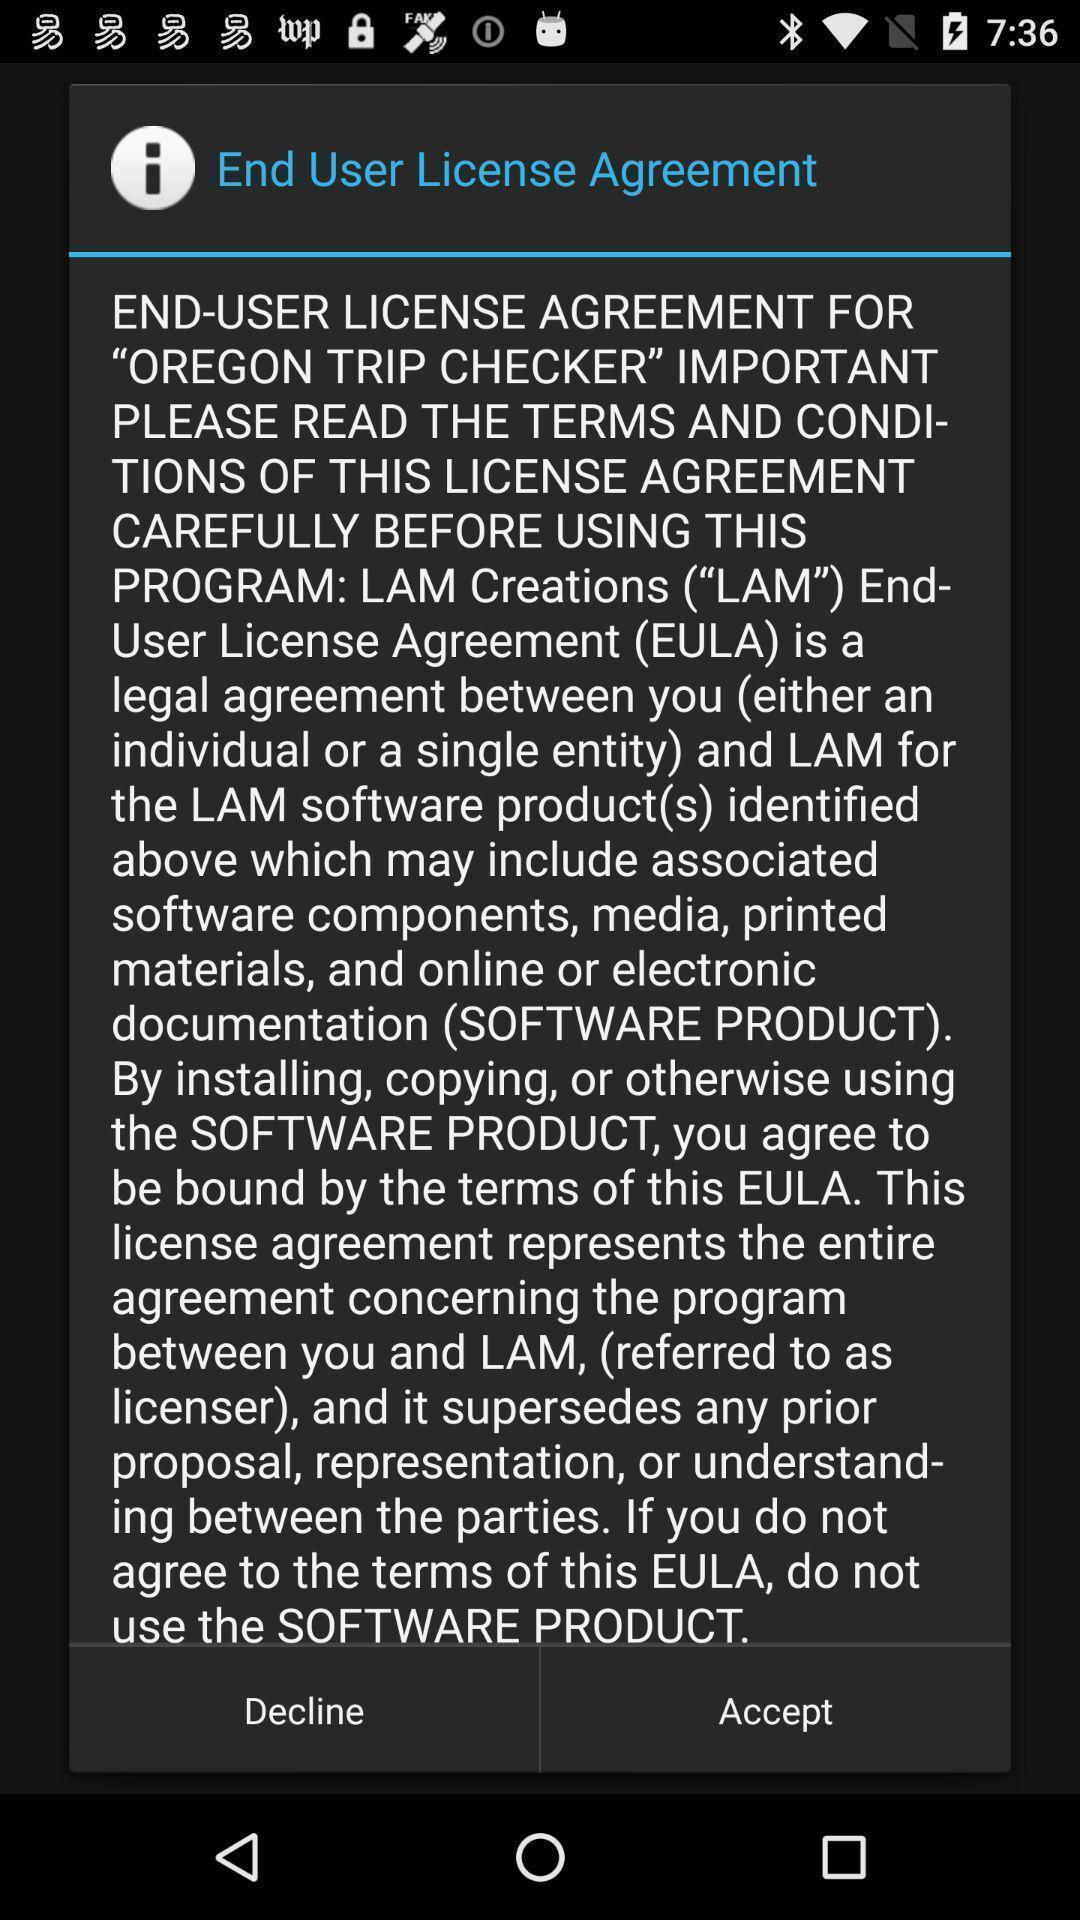Tell me about the visual elements in this screen capture. Pop-up displaying to accept the agreement. 